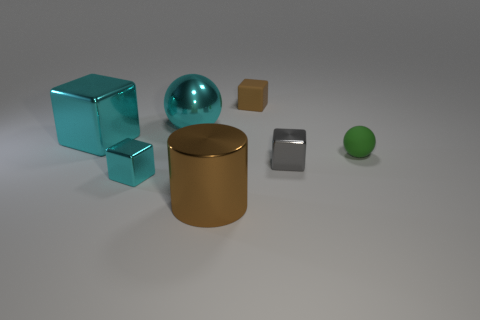Subtract 1 cubes. How many cubes are left? 3 Add 2 large brown metal things. How many objects exist? 9 Subtract all blocks. How many objects are left? 3 Subtract all big yellow matte objects. Subtract all cyan balls. How many objects are left? 6 Add 6 gray blocks. How many gray blocks are left? 7 Add 5 yellow shiny objects. How many yellow shiny objects exist? 5 Subtract 0 yellow cylinders. How many objects are left? 7 